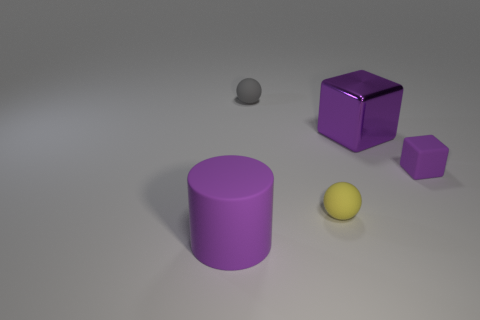Add 2 large red metal balls. How many objects exist? 7 Subtract all cylinders. How many objects are left? 4 Add 4 matte things. How many matte things exist? 8 Subtract 1 yellow balls. How many objects are left? 4 Subtract all rubber cylinders. Subtract all tiny purple matte things. How many objects are left? 3 Add 5 purple matte cylinders. How many purple matte cylinders are left? 6 